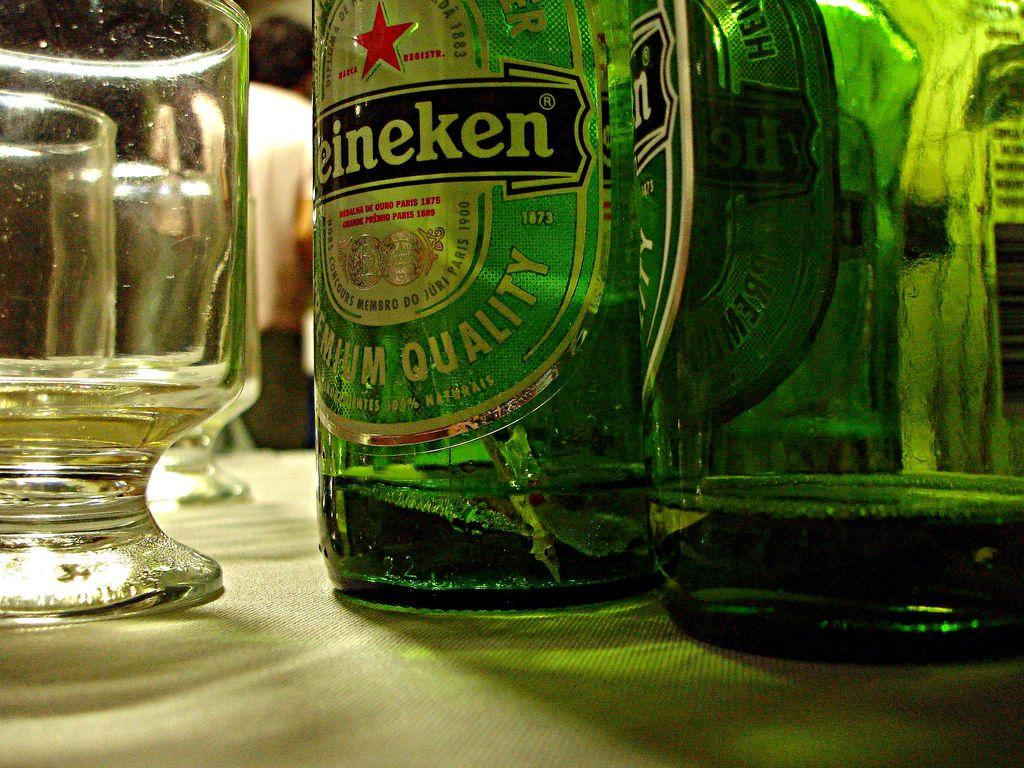<image>
Give a short and clear explanation of the subsequent image. Some bottles of Heineken are on a table. 